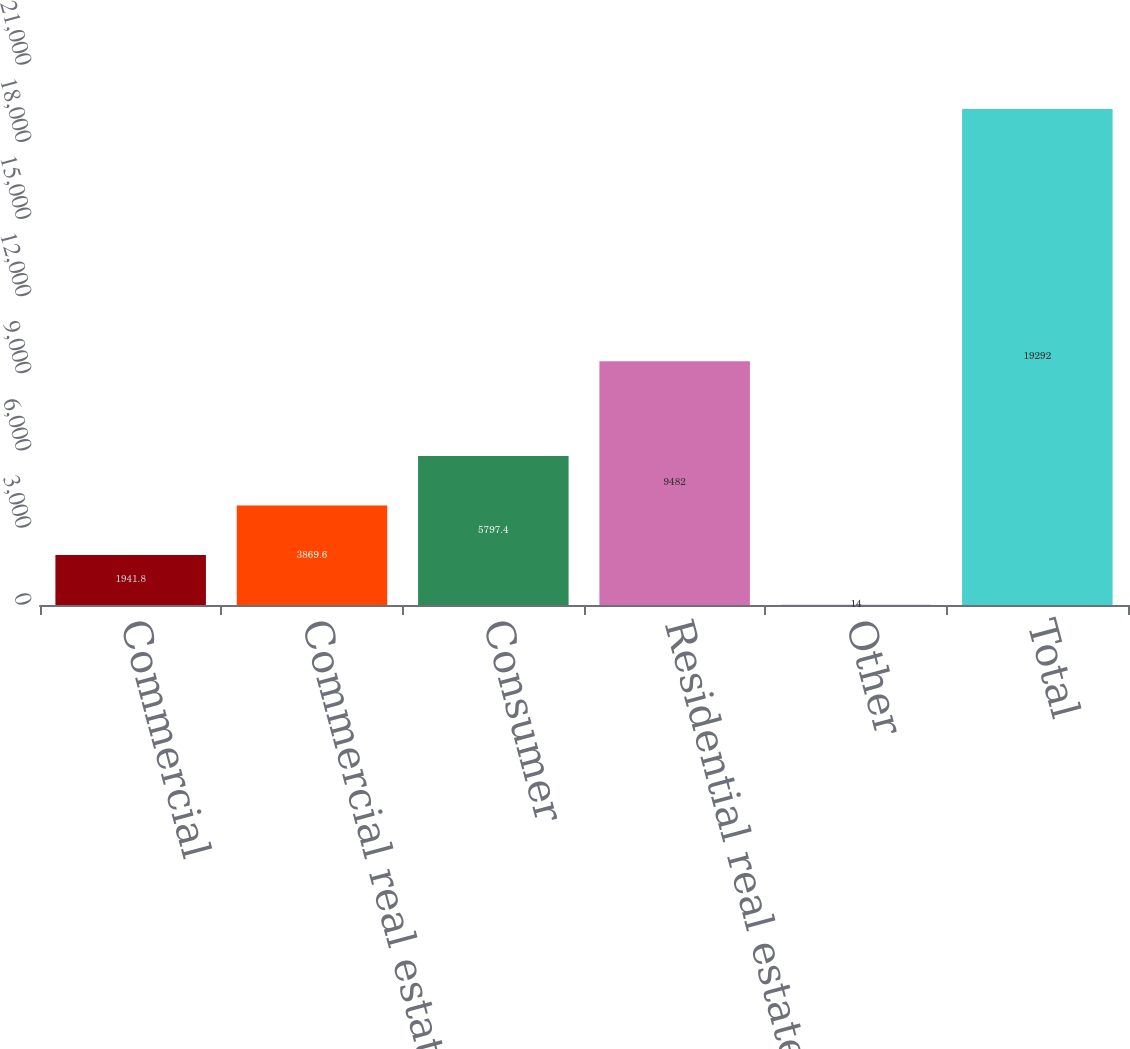Convert chart to OTSL. <chart><loc_0><loc_0><loc_500><loc_500><bar_chart><fcel>Commercial<fcel>Commercial real estate<fcel>Consumer<fcel>Residential real estate<fcel>Other<fcel>Total<nl><fcel>1941.8<fcel>3869.6<fcel>5797.4<fcel>9482<fcel>14<fcel>19292<nl></chart> 